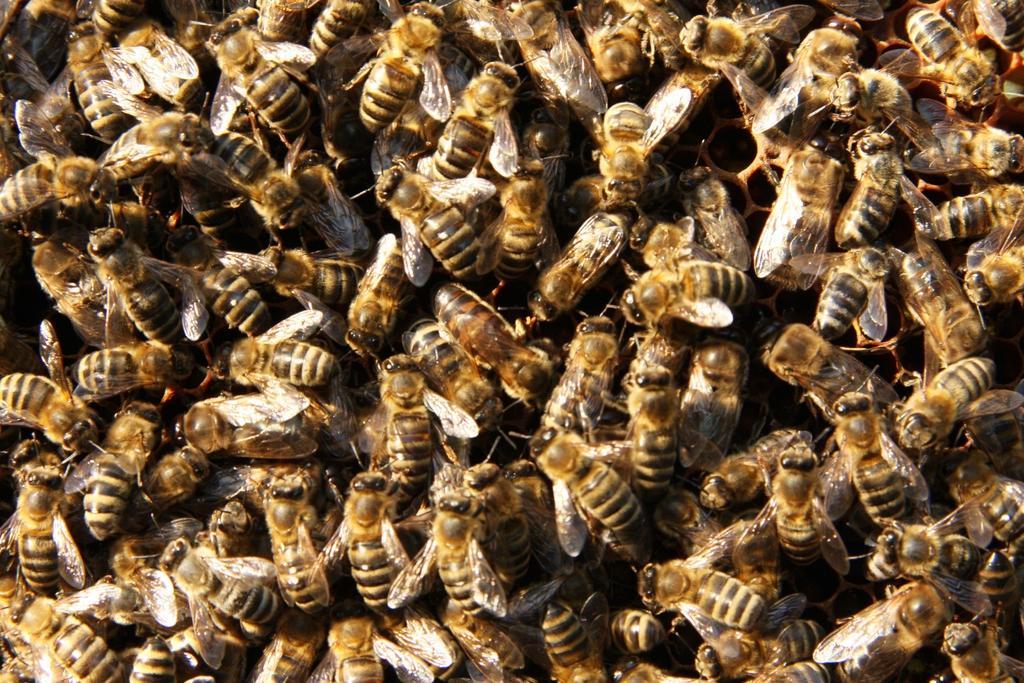Describe this image in one or two sentences. This is the image of group of honey bees. 